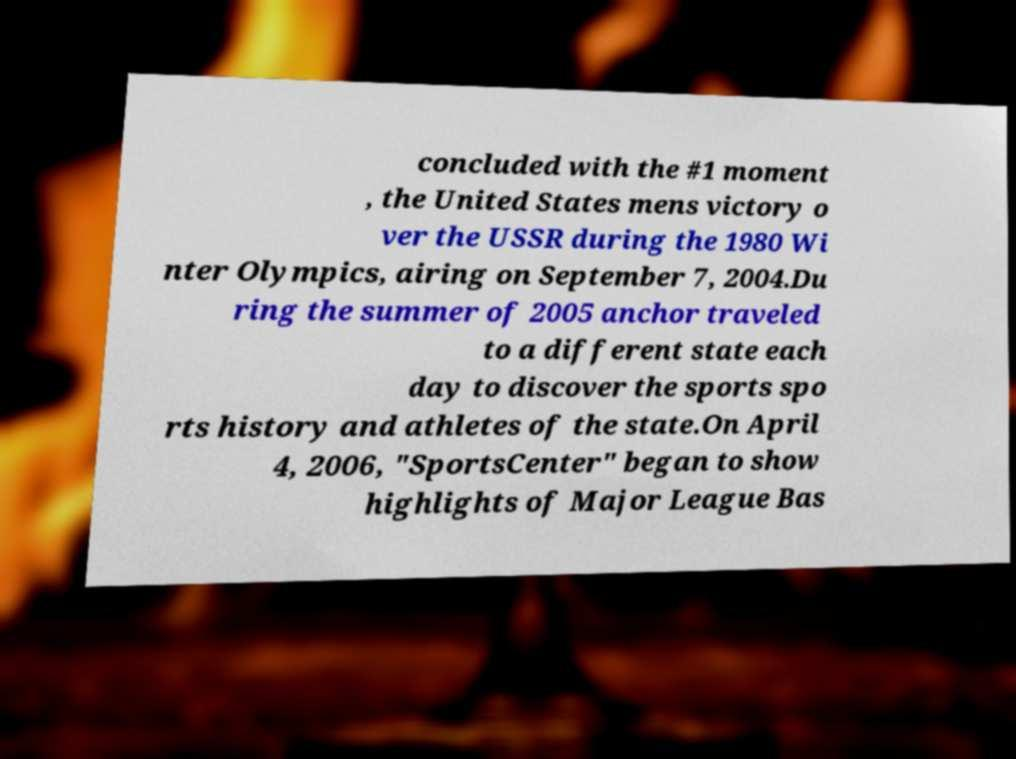I need the written content from this picture converted into text. Can you do that? concluded with the #1 moment , the United States mens victory o ver the USSR during the 1980 Wi nter Olympics, airing on September 7, 2004.Du ring the summer of 2005 anchor traveled to a different state each day to discover the sports spo rts history and athletes of the state.On April 4, 2006, "SportsCenter" began to show highlights of Major League Bas 